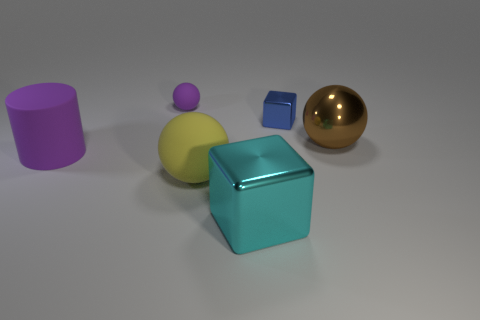Do the blue thing and the large cyan metal object have the same shape?
Your answer should be very brief. Yes. The block that is the same size as the brown shiny object is what color?
Your answer should be compact. Cyan. The brown metallic thing that is the same shape as the large yellow object is what size?
Your response must be concise. Large. There is a large cyan metal object that is in front of the blue block; what is its shape?
Your answer should be compact. Cube. Is the shape of the small blue shiny object the same as the tiny object on the left side of the cyan thing?
Offer a very short reply. No. Is the number of big cyan cubes that are in front of the large cyan metal cube the same as the number of rubber objects to the right of the small blue block?
Offer a terse response. Yes. What is the shape of the other rubber object that is the same color as the small rubber object?
Give a very brief answer. Cylinder. Does the shiny block in front of the small cube have the same color as the metal thing on the right side of the blue shiny cube?
Provide a short and direct response. No. Are there more big matte objects that are in front of the big block than small rubber objects?
Make the answer very short. No. What is the material of the small purple ball?
Give a very brief answer. Rubber. 